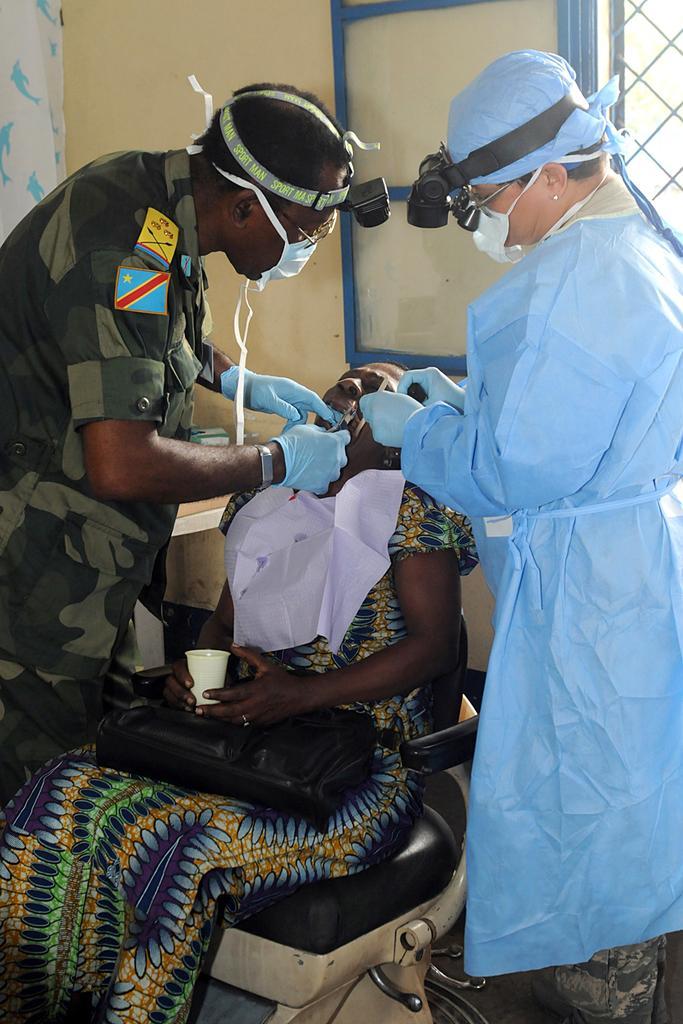Can you describe this image briefly? There one woman holding a glass and sitting on the chair as we can see at the bottom of this image. We can see a man on the left side of this image and a person is on the right side of this image as well. We can see a wall in the background. 